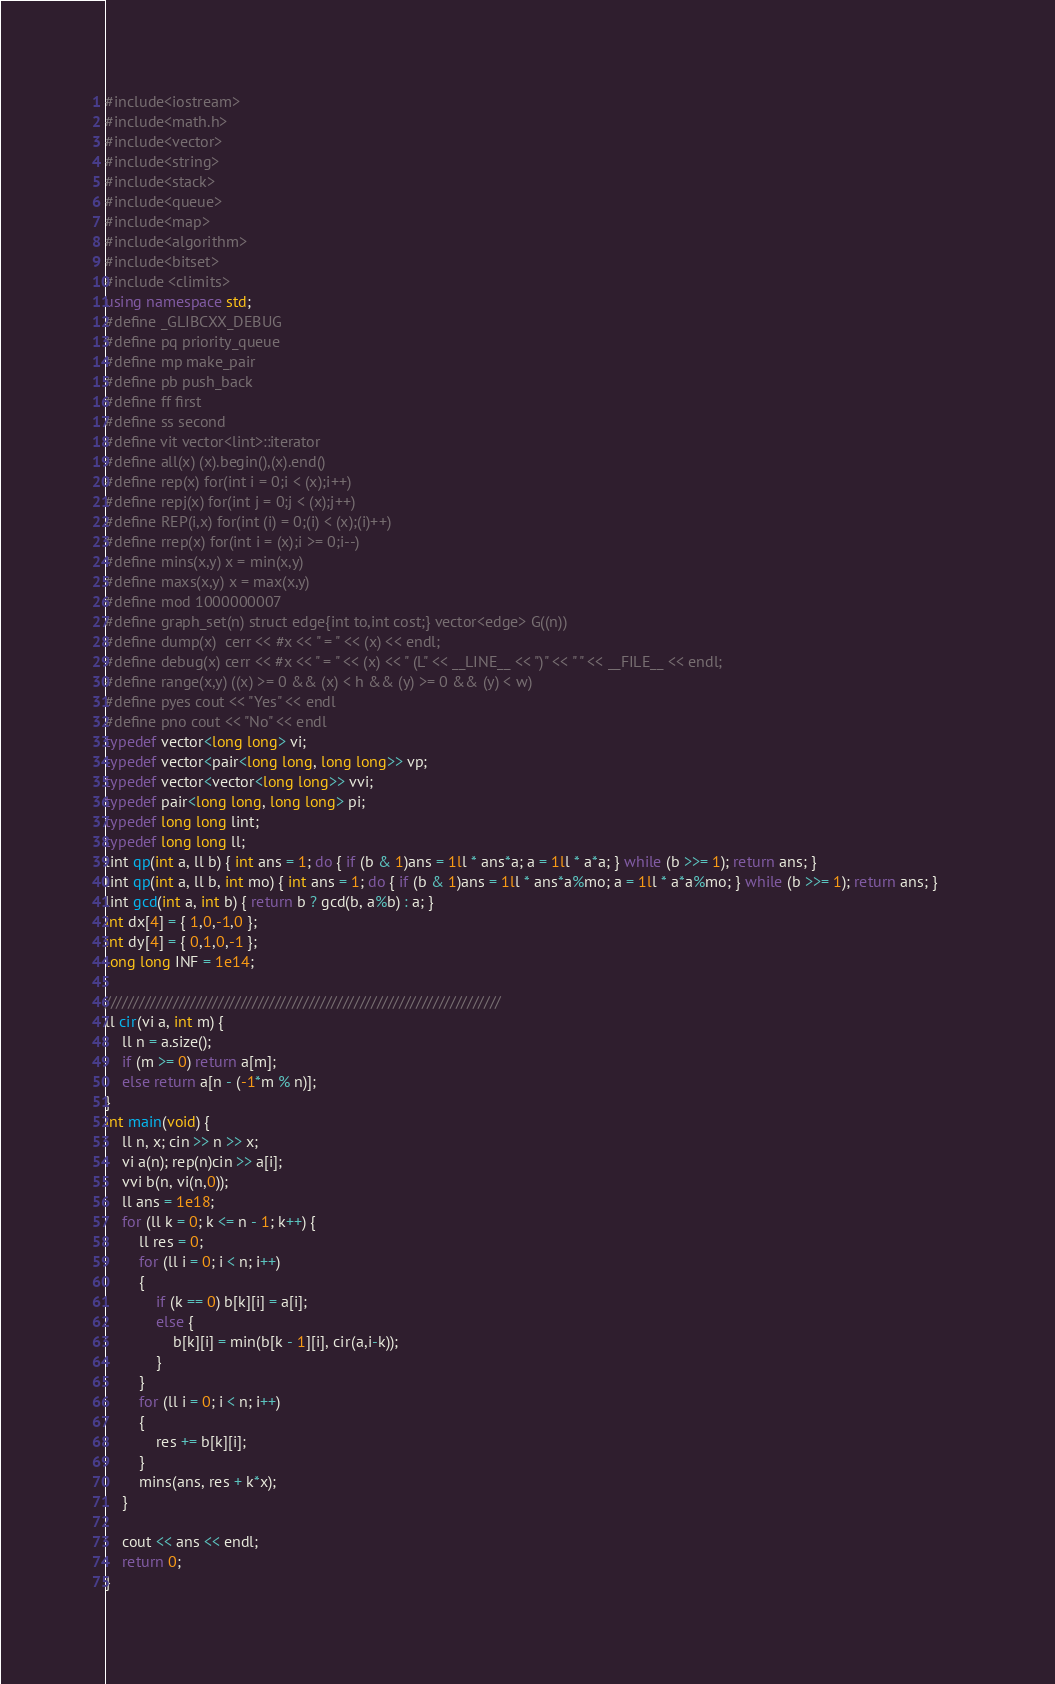Convert code to text. <code><loc_0><loc_0><loc_500><loc_500><_C++_>#include<iostream>
#include<math.h>
#include<vector>
#include<string>
#include<stack>
#include<queue>
#include<map>
#include<algorithm>
#include<bitset>
#include <climits>
using namespace std;
#define _GLIBCXX_DEBUG
#define pq priority_queue
#define mp make_pair
#define pb push_back
#define ff first
#define ss second
#define vit vector<lint>::iterator
#define all(x) (x).begin(),(x).end()
#define rep(x) for(int i = 0;i < (x);i++)
#define repj(x) for(int j = 0;j < (x);j++)
#define REP(i,x) for(int (i) = 0;(i) < (x);(i)++)
#define rrep(x) for(int i = (x);i >= 0;i--)
#define mins(x,y) x = min(x,y)
#define maxs(x,y) x = max(x,y)
#define mod 1000000007
#define graph_set(n) struct edge{int to,int cost;} vector<edge> G((n))
#define dump(x)  cerr << #x << " = " << (x) << endl;
#define debug(x) cerr << #x << " = " << (x) << " (L" << __LINE__ << ")" << " " << __FILE__ << endl;
#define range(x,y) ((x) >= 0 && (x) < h && (y) >= 0 && (y) < w)
#define pyes cout << "Yes" << endl
#define pno cout << "No" << endl
typedef vector<long long> vi;
typedef vector<pair<long long, long long>> vp;
typedef vector<vector<long long>> vvi;
typedef pair<long long, long long> pi;
typedef long long lint;
typedef long long ll;
lint qp(int a, ll b) { int ans = 1; do { if (b & 1)ans = 1ll * ans*a; a = 1ll * a*a; } while (b >>= 1); return ans; }
lint qp(int a, ll b, int mo) { int ans = 1; do { if (b & 1)ans = 1ll * ans*a%mo; a = 1ll * a*a%mo; } while (b >>= 1); return ans; }
lint gcd(int a, int b) { return b ? gcd(b, a%b) : a; }                                                                                                                            
int dx[4] = { 1,0,-1,0 };
int dy[4] = { 0,1,0,-1 };
long long INF = 1e14;

//////////////////////////////////////////////////////////////////////
ll cir(vi a, int m) {
	ll n = a.size();
	if (m >= 0) return a[m];
	else return a[n - (-1*m % n)];
}
int main(void) {
	ll n, x; cin >> n >> x;
	vi a(n); rep(n)cin >> a[i];
	vvi b(n, vi(n,0));
	ll ans = 1e18;
	for (ll k = 0; k <= n - 1; k++) {
		ll res = 0;
		for (ll i = 0; i < n; i++)
		{
			if (k == 0) b[k][i] = a[i];
			else {
				b[k][i] = min(b[k - 1][i], cir(a,i-k));
			}
		}
		for (ll i = 0; i < n; i++)
		{
			res += b[k][i];
		}
		mins(ans, res + k*x);
	}

	cout << ans << endl;
	return 0;
}</code> 